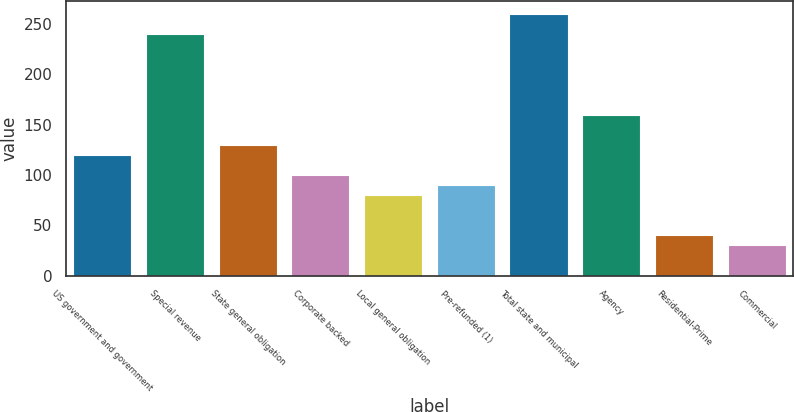Convert chart. <chart><loc_0><loc_0><loc_500><loc_500><bar_chart><fcel>US government and government<fcel>Special revenue<fcel>State general obligation<fcel>Corporate backed<fcel>Local general obligation<fcel>Pre-refunded (1)<fcel>Total state and municipal<fcel>Agency<fcel>Residential-Prime<fcel>Commercial<nl><fcel>119.96<fcel>239.72<fcel>129.94<fcel>100<fcel>80.04<fcel>90.02<fcel>259.68<fcel>159.88<fcel>40.12<fcel>30.14<nl></chart> 